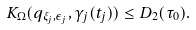<formula> <loc_0><loc_0><loc_500><loc_500>K _ { \Omega } ( q _ { \xi _ { j } , \epsilon _ { j } } , \gamma _ { j } ( t _ { j } ) ) \leq D _ { 2 } ( \tau _ { 0 } ) .</formula> 